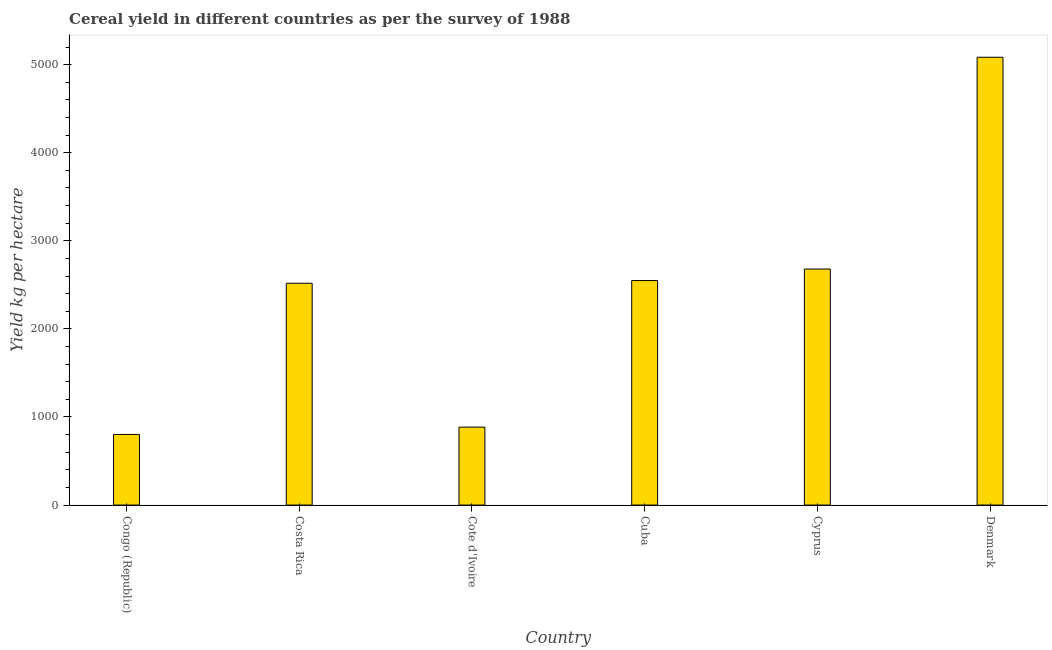Does the graph contain any zero values?
Ensure brevity in your answer.  No. What is the title of the graph?
Give a very brief answer. Cereal yield in different countries as per the survey of 1988. What is the label or title of the Y-axis?
Your answer should be compact. Yield kg per hectare. What is the cereal yield in Cote d'Ivoire?
Give a very brief answer. 885.06. Across all countries, what is the maximum cereal yield?
Your response must be concise. 5084.24. Across all countries, what is the minimum cereal yield?
Offer a very short reply. 801.86. In which country was the cereal yield maximum?
Your response must be concise. Denmark. In which country was the cereal yield minimum?
Ensure brevity in your answer.  Congo (Republic). What is the sum of the cereal yield?
Keep it short and to the point. 1.45e+04. What is the difference between the cereal yield in Costa Rica and Cote d'Ivoire?
Offer a very short reply. 1633.29. What is the average cereal yield per country?
Ensure brevity in your answer.  2419.75. What is the median cereal yield?
Offer a terse response. 2533.72. In how many countries, is the cereal yield greater than 3400 kg per hectare?
Offer a very short reply. 1. What is the ratio of the cereal yield in Costa Rica to that in Cuba?
Offer a terse response. 0.99. Is the cereal yield in Costa Rica less than that in Denmark?
Your answer should be very brief. Yes. What is the difference between the highest and the second highest cereal yield?
Provide a short and direct response. 2404.32. Is the sum of the cereal yield in Congo (Republic) and Denmark greater than the maximum cereal yield across all countries?
Provide a succinct answer. Yes. What is the difference between the highest and the lowest cereal yield?
Give a very brief answer. 4282.39. How many countries are there in the graph?
Offer a terse response. 6. What is the Yield kg per hectare of Congo (Republic)?
Keep it short and to the point. 801.86. What is the Yield kg per hectare of Costa Rica?
Provide a short and direct response. 2518.34. What is the Yield kg per hectare of Cote d'Ivoire?
Your answer should be compact. 885.06. What is the Yield kg per hectare of Cuba?
Your answer should be compact. 2549.09. What is the Yield kg per hectare in Cyprus?
Your response must be concise. 2679.92. What is the Yield kg per hectare of Denmark?
Your response must be concise. 5084.24. What is the difference between the Yield kg per hectare in Congo (Republic) and Costa Rica?
Provide a succinct answer. -1716.49. What is the difference between the Yield kg per hectare in Congo (Republic) and Cote d'Ivoire?
Your answer should be compact. -83.2. What is the difference between the Yield kg per hectare in Congo (Republic) and Cuba?
Ensure brevity in your answer.  -1747.23. What is the difference between the Yield kg per hectare in Congo (Republic) and Cyprus?
Offer a terse response. -1878.06. What is the difference between the Yield kg per hectare in Congo (Republic) and Denmark?
Ensure brevity in your answer.  -4282.39. What is the difference between the Yield kg per hectare in Costa Rica and Cote d'Ivoire?
Offer a very short reply. 1633.29. What is the difference between the Yield kg per hectare in Costa Rica and Cuba?
Your answer should be very brief. -30.74. What is the difference between the Yield kg per hectare in Costa Rica and Cyprus?
Make the answer very short. -161.58. What is the difference between the Yield kg per hectare in Costa Rica and Denmark?
Make the answer very short. -2565.9. What is the difference between the Yield kg per hectare in Cote d'Ivoire and Cuba?
Make the answer very short. -1664.03. What is the difference between the Yield kg per hectare in Cote d'Ivoire and Cyprus?
Offer a terse response. -1794.86. What is the difference between the Yield kg per hectare in Cote d'Ivoire and Denmark?
Offer a terse response. -4199.19. What is the difference between the Yield kg per hectare in Cuba and Cyprus?
Give a very brief answer. -130.83. What is the difference between the Yield kg per hectare in Cuba and Denmark?
Your answer should be compact. -2535.16. What is the difference between the Yield kg per hectare in Cyprus and Denmark?
Ensure brevity in your answer.  -2404.32. What is the ratio of the Yield kg per hectare in Congo (Republic) to that in Costa Rica?
Keep it short and to the point. 0.32. What is the ratio of the Yield kg per hectare in Congo (Republic) to that in Cote d'Ivoire?
Your answer should be compact. 0.91. What is the ratio of the Yield kg per hectare in Congo (Republic) to that in Cuba?
Your answer should be compact. 0.32. What is the ratio of the Yield kg per hectare in Congo (Republic) to that in Cyprus?
Make the answer very short. 0.3. What is the ratio of the Yield kg per hectare in Congo (Republic) to that in Denmark?
Make the answer very short. 0.16. What is the ratio of the Yield kg per hectare in Costa Rica to that in Cote d'Ivoire?
Provide a succinct answer. 2.85. What is the ratio of the Yield kg per hectare in Costa Rica to that in Cyprus?
Provide a succinct answer. 0.94. What is the ratio of the Yield kg per hectare in Costa Rica to that in Denmark?
Offer a very short reply. 0.49. What is the ratio of the Yield kg per hectare in Cote d'Ivoire to that in Cuba?
Keep it short and to the point. 0.35. What is the ratio of the Yield kg per hectare in Cote d'Ivoire to that in Cyprus?
Ensure brevity in your answer.  0.33. What is the ratio of the Yield kg per hectare in Cote d'Ivoire to that in Denmark?
Your answer should be very brief. 0.17. What is the ratio of the Yield kg per hectare in Cuba to that in Cyprus?
Offer a terse response. 0.95. What is the ratio of the Yield kg per hectare in Cuba to that in Denmark?
Make the answer very short. 0.5. What is the ratio of the Yield kg per hectare in Cyprus to that in Denmark?
Provide a short and direct response. 0.53. 